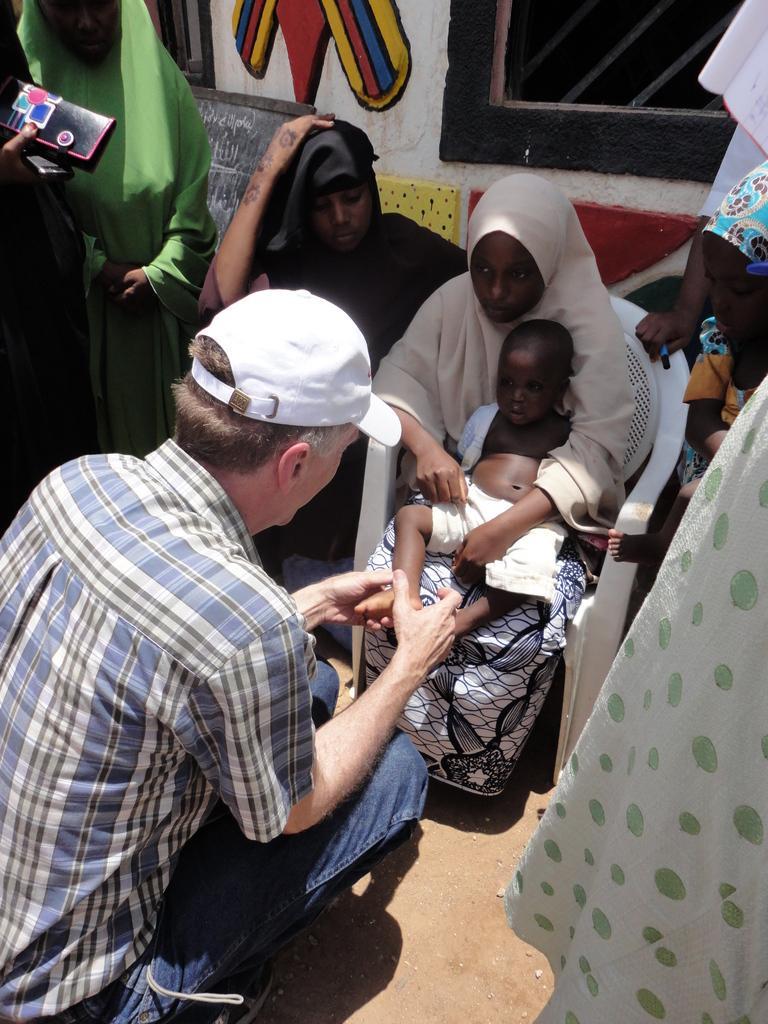In one or two sentences, can you explain what this image depicts? In this image, we can see a woman sitting on the chair, she is holding the kid, there is a man sitting and he is wearing a white color hat, there are some people standing and we can see a window. 